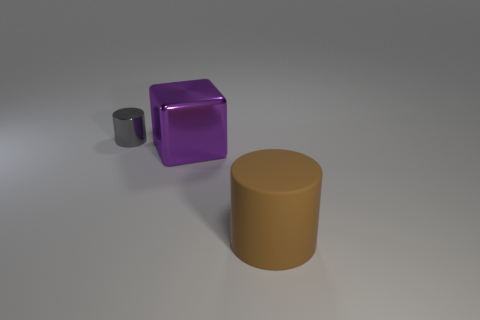What shape is the brown object?
Offer a terse response. Cylinder. There is a matte object that is the same shape as the tiny gray metallic thing; what size is it?
Provide a short and direct response. Large. Is there anything else that has the same material as the brown thing?
Make the answer very short. No. There is a cylinder behind the cylinder that is to the right of the small gray metallic thing; what size is it?
Your answer should be very brief. Small. Are there an equal number of large brown rubber cylinders that are left of the gray thing and tiny metal objects?
Your answer should be compact. No. Is the number of brown cylinders on the right side of the brown object less than the number of big purple metallic things?
Your answer should be compact. Yes. Are there any blocks of the same size as the purple thing?
Your answer should be very brief. No. There is a cylinder that is in front of the small object; how many brown rubber objects are on the left side of it?
Your answer should be compact. 0. There is a large thing behind the thing on the right side of the big purple block; what color is it?
Provide a short and direct response. Purple. Are there any other rubber things of the same shape as the gray object?
Offer a very short reply. Yes. 